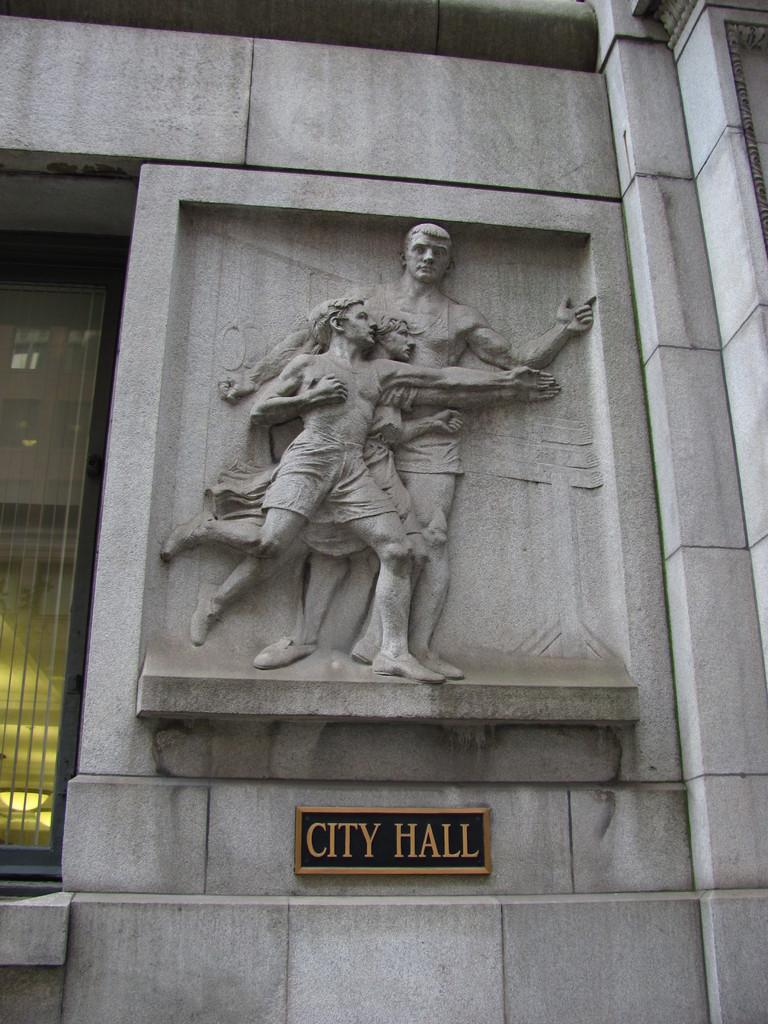What is on the wall in the image? There is a sculpture on the wall in the image. What is located under the sculpture on the wall? There is a name board attached to the wall under the sculpture. What can be seen on the left side of the image? There is a glass on the left side of the image. What type of waste is visible on the ground in the image? There is no waste or ground visible in the image; it only shows a sculpture, a name board, and a glass. What type of juice is being served in the glass in the image? There is no juice or indication of its contents in the glass in the image. 